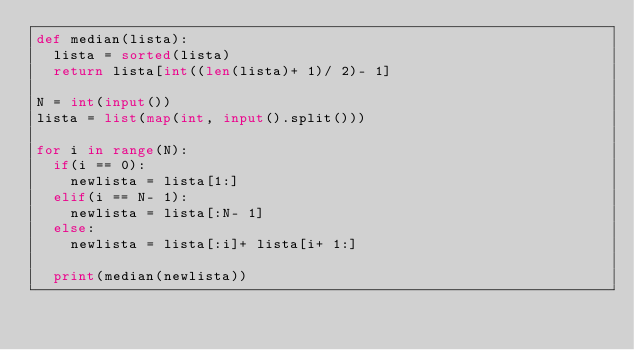<code> <loc_0><loc_0><loc_500><loc_500><_Python_>def median(lista):
  lista = sorted(lista)
  return lista[int((len(lista)+ 1)/ 2)- 1]

N = int(input())
lista = list(map(int, input().split()))

for i in range(N):
  if(i == 0):
    newlista = lista[1:]
  elif(i == N- 1):
    newlista = lista[:N- 1]
  else:
  	newlista = lista[:i]+ lista[i+ 1:]
   
  print(median(newlista))</code> 